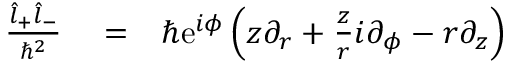<formula> <loc_0><loc_0><loc_500><loc_500>\begin{array} { r l r } { \frac { \hat { l } _ { + } \hat { l } _ { - } } { \hbar { ^ } { 2 } } } & = } & { \hbar { e } ^ { i \phi } \left ( z \partial _ { r } + \frac { z } { r } i \partial _ { \phi } - r \partial _ { z } \right ) } \end{array}</formula> 